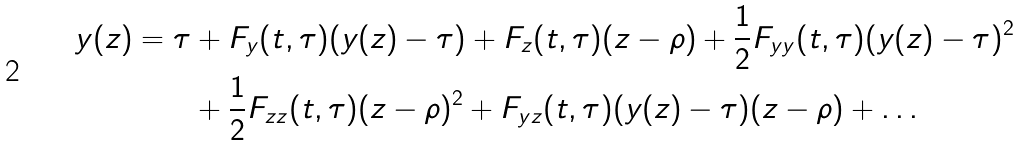<formula> <loc_0><loc_0><loc_500><loc_500>y ( z ) = \tau & + F _ { y } ( t , \tau ) ( y ( z ) - \tau ) + F _ { z } ( t , \tau ) ( z - \rho ) + \frac { 1 } { 2 } F _ { y y } ( t , \tau ) ( y ( z ) - \tau ) ^ { 2 } \\ & + \frac { 1 } { 2 } F _ { z z } ( t , \tau ) ( z - \rho ) ^ { 2 } + F _ { y z } ( t , \tau ) ( y ( z ) - \tau ) ( z - \rho ) + \dots</formula> 